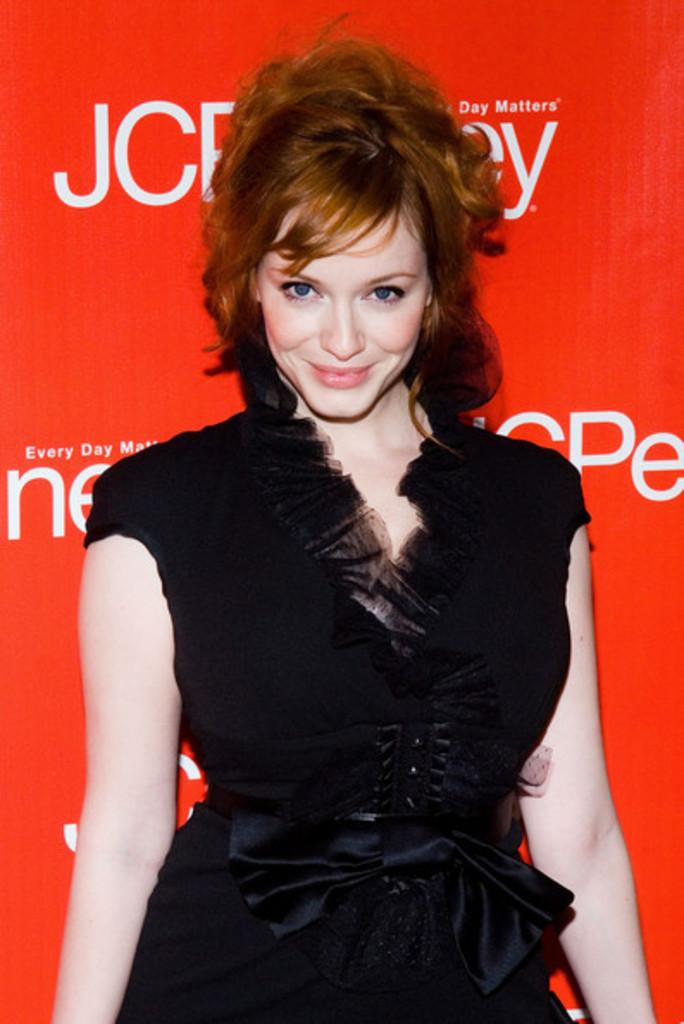Who is present in the image? There is a woman in the image. What is the woman wearing? The woman is wearing a black dress. What expression does the woman have? The woman is smiling. What position is the woman in? The woman is standing. What can be seen in the background of the image? There are white texts on a red surface in the background of the image. Is there a fight happening between the woman and someone else in the image? No, there is no fight depicted in the image; the woman is smiling and standing alone. 